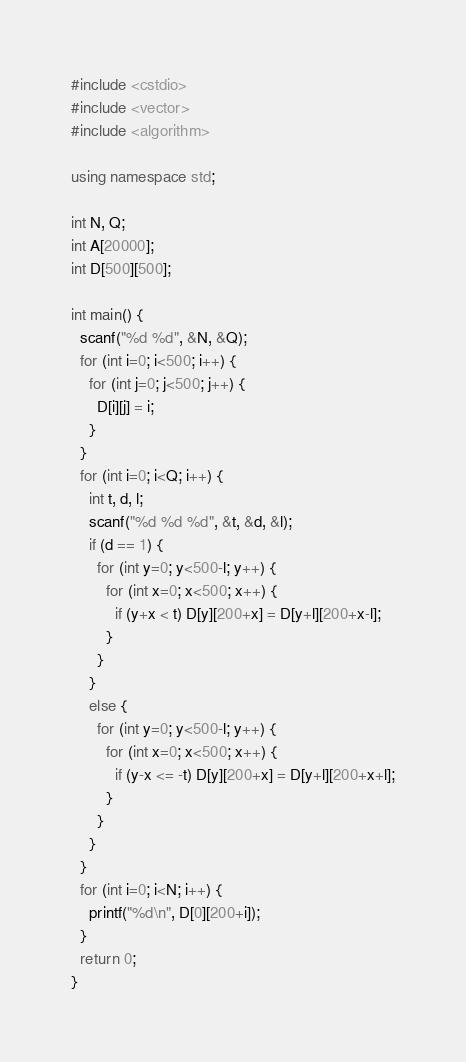Convert code to text. <code><loc_0><loc_0><loc_500><loc_500><_C++_>#include <cstdio>
#include <vector>
#include <algorithm>

using namespace std;

int N, Q;
int A[20000];
int D[500][500];

int main() {
  scanf("%d %d", &N, &Q);
  for (int i=0; i<500; i++) {
    for (int j=0; j<500; j++) {
      D[i][j] = i;
    }
  }
  for (int i=0; i<Q; i++) {
    int t, d, l;
    scanf("%d %d %d", &t, &d, &l);
    if (d == 1) {
      for (int y=0; y<500-l; y++) {
        for (int x=0; x<500; x++) {
          if (y+x < t) D[y][200+x] = D[y+l][200+x-l];
        }
      }
    }
    else {
      for (int y=0; y<500-l; y++) {
        for (int x=0; x<500; x++) {
          if (y-x <= -t) D[y][200+x] = D[y+l][200+x+l];
        }
      }
    }
  }
  for (int i=0; i<N; i++) {
    printf("%d\n", D[0][200+i]);
  }
  return 0;
}</code> 